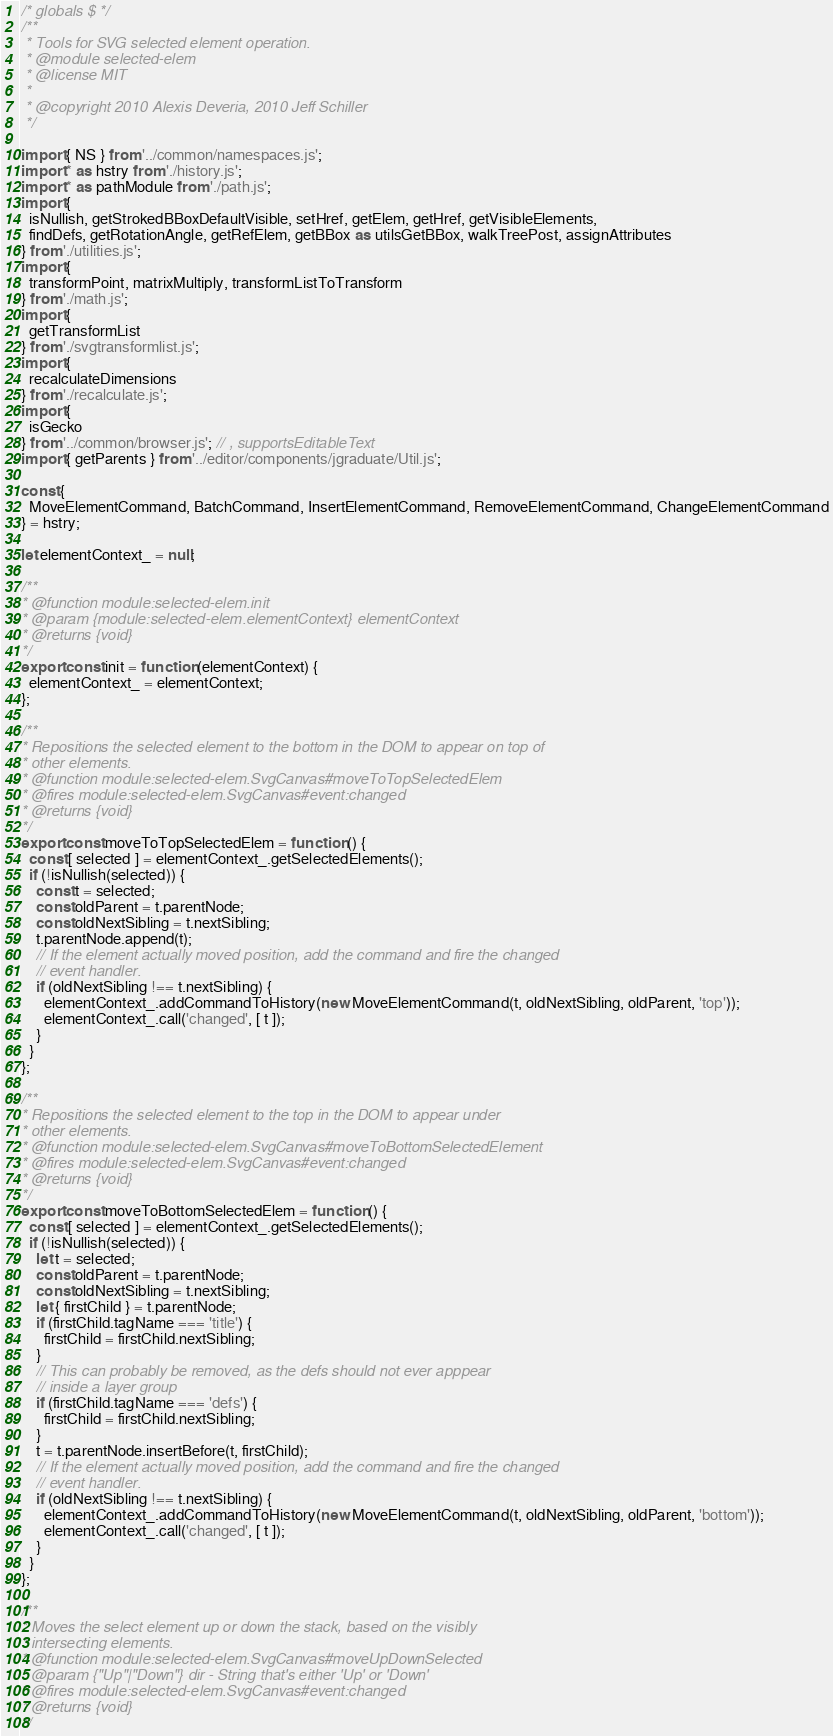Convert code to text. <code><loc_0><loc_0><loc_500><loc_500><_JavaScript_>/* globals $ */
/**
 * Tools for SVG selected element operation.
 * @module selected-elem
 * @license MIT
 *
 * @copyright 2010 Alexis Deveria, 2010 Jeff Schiller
 */

import { NS } from '../common/namespaces.js';
import * as hstry from './history.js';
import * as pathModule from './path.js';
import {
  isNullish, getStrokedBBoxDefaultVisible, setHref, getElem, getHref, getVisibleElements,
  findDefs, getRotationAngle, getRefElem, getBBox as utilsGetBBox, walkTreePost, assignAttributes
} from './utilities.js';
import {
  transformPoint, matrixMultiply, transformListToTransform
} from './math.js';
import {
  getTransformList
} from './svgtransformlist.js';
import {
  recalculateDimensions
} from './recalculate.js';
import {
  isGecko
} from '../common/browser.js'; // , supportsEditableText
import { getParents } from '../editor/components/jgraduate/Util.js';

const {
  MoveElementCommand, BatchCommand, InsertElementCommand, RemoveElementCommand, ChangeElementCommand
} = hstry;

let elementContext_ = null;

/**
* @function module:selected-elem.init
* @param {module:selected-elem.elementContext} elementContext
* @returns {void}
*/
export const init = function (elementContext) {
  elementContext_ = elementContext;
};

/**
* Repositions the selected element to the bottom in the DOM to appear on top of
* other elements.
* @function module:selected-elem.SvgCanvas#moveToTopSelectedElem
* @fires module:selected-elem.SvgCanvas#event:changed
* @returns {void}
*/
export const moveToTopSelectedElem = function () {
  const [ selected ] = elementContext_.getSelectedElements();
  if (!isNullish(selected)) {
    const t = selected;
    const oldParent = t.parentNode;
    const oldNextSibling = t.nextSibling;
    t.parentNode.append(t);
    // If the element actually moved position, add the command and fire the changed
    // event handler.
    if (oldNextSibling !== t.nextSibling) {
      elementContext_.addCommandToHistory(new MoveElementCommand(t, oldNextSibling, oldParent, 'top'));
      elementContext_.call('changed', [ t ]);
    }
  }
};

/**
* Repositions the selected element to the top in the DOM to appear under
* other elements.
* @function module:selected-elem.SvgCanvas#moveToBottomSelectedElement
* @fires module:selected-elem.SvgCanvas#event:changed
* @returns {void}
*/
export const moveToBottomSelectedElem = function () {
  const [ selected ] = elementContext_.getSelectedElements();
  if (!isNullish(selected)) {
    let t = selected;
    const oldParent = t.parentNode;
    const oldNextSibling = t.nextSibling;
    let { firstChild } = t.parentNode;
    if (firstChild.tagName === 'title') {
      firstChild = firstChild.nextSibling;
    }
    // This can probably be removed, as the defs should not ever apppear
    // inside a layer group
    if (firstChild.tagName === 'defs') {
      firstChild = firstChild.nextSibling;
    }
    t = t.parentNode.insertBefore(t, firstChild);
    // If the element actually moved position, add the command and fire the changed
    // event handler.
    if (oldNextSibling !== t.nextSibling) {
      elementContext_.addCommandToHistory(new MoveElementCommand(t, oldNextSibling, oldParent, 'bottom'));
      elementContext_.call('changed', [ t ]);
    }
  }
};

/**
* Moves the select element up or down the stack, based on the visibly
* intersecting elements.
* @function module:selected-elem.SvgCanvas#moveUpDownSelected
* @param {"Up"|"Down"} dir - String that's either 'Up' or 'Down'
* @fires module:selected-elem.SvgCanvas#event:changed
* @returns {void}
*/</code> 